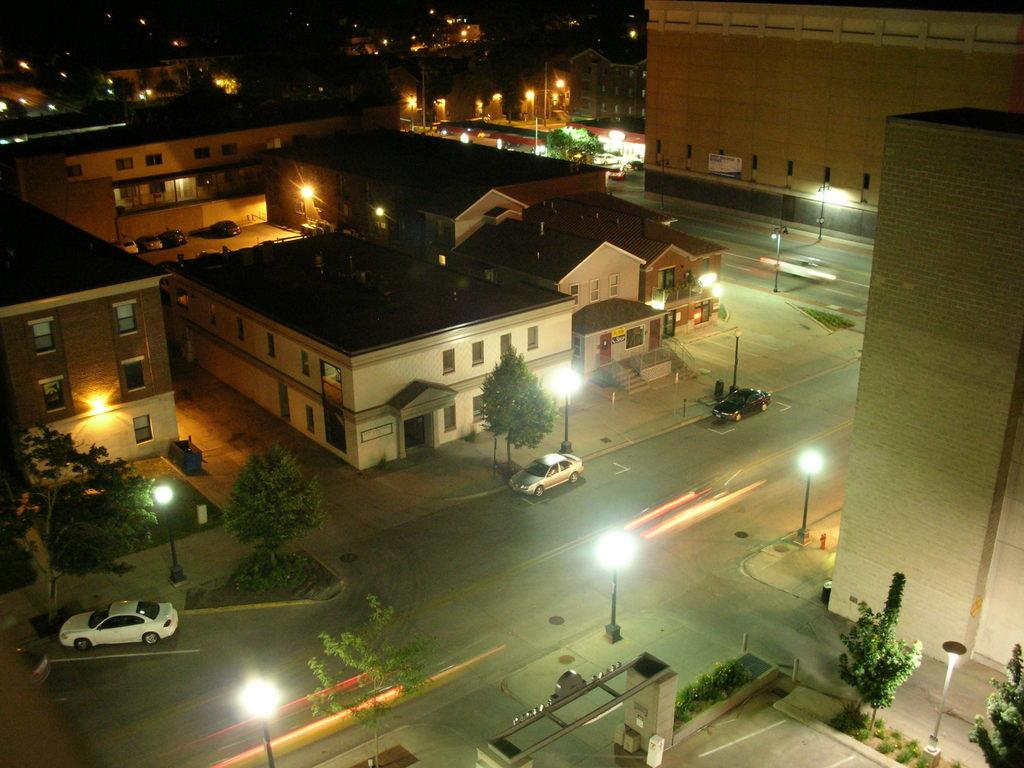What types of objects can be seen in the image? There are vehicles, buildings, trees, plants, poles, lights, and an arch in the image. What is the ground like in the image? The ground is visible in the image with some objects. Are there any natural elements present in the image? Yes, there are trees and grass in the image. Can you describe the arch in the image? There is an arch in the image, but its specific details cannot be determined from the provided facts. What type of appliance is visible on the furniture in the image? There is no furniture or appliance present in the image; it features vehicles, buildings, trees, plants, poles, lights, an arch, and grass. What question is being asked in the image? There is no question present in the image; it is a visual representation of various objects and elements. 